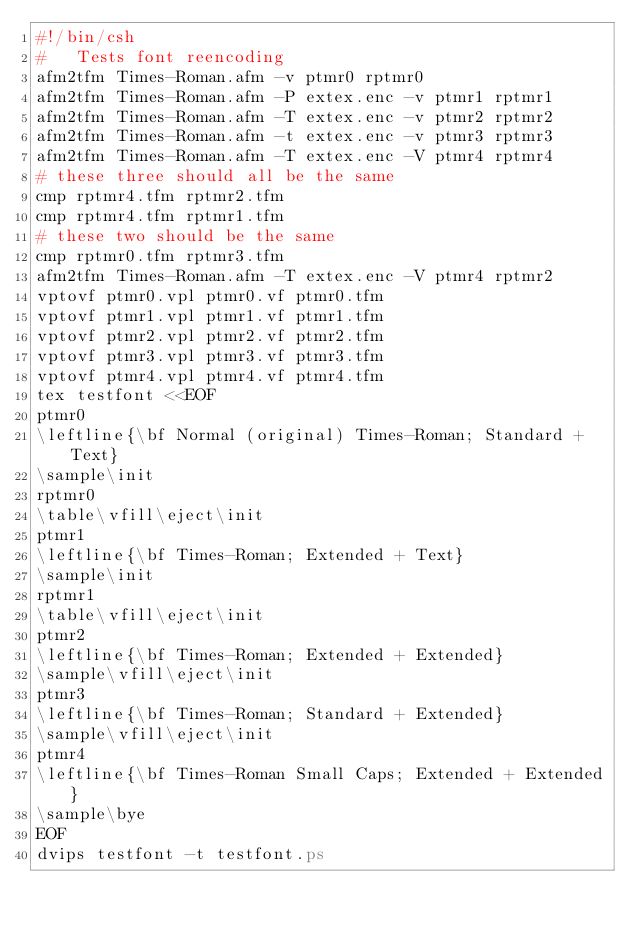Convert code to text. <code><loc_0><loc_0><loc_500><loc_500><_Bash_>#!/bin/csh
#   Tests font reencoding
afm2tfm Times-Roman.afm -v ptmr0 rptmr0
afm2tfm Times-Roman.afm -P extex.enc -v ptmr1 rptmr1
afm2tfm Times-Roman.afm -T extex.enc -v ptmr2 rptmr2
afm2tfm Times-Roman.afm -t extex.enc -v ptmr3 rptmr3
afm2tfm Times-Roman.afm -T extex.enc -V ptmr4 rptmr4
# these three should all be the same
cmp rptmr4.tfm rptmr2.tfm
cmp rptmr4.tfm rptmr1.tfm
# these two should be the same
cmp rptmr0.tfm rptmr3.tfm
afm2tfm Times-Roman.afm -T extex.enc -V ptmr4 rptmr2
vptovf ptmr0.vpl ptmr0.vf ptmr0.tfm
vptovf ptmr1.vpl ptmr1.vf ptmr1.tfm
vptovf ptmr2.vpl ptmr2.vf ptmr2.tfm
vptovf ptmr3.vpl ptmr3.vf ptmr3.tfm
vptovf ptmr4.vpl ptmr4.vf ptmr4.tfm
tex testfont <<EOF
ptmr0
\leftline{\bf Normal (original) Times-Roman; Standard + Text}
\sample\init
rptmr0
\table\vfill\eject\init
ptmr1
\leftline{\bf Times-Roman; Extended + Text}
\sample\init
rptmr1
\table\vfill\eject\init
ptmr2
\leftline{\bf Times-Roman; Extended + Extended}
\sample\vfill\eject\init
ptmr3
\leftline{\bf Times-Roman; Standard + Extended}
\sample\vfill\eject\init
ptmr4
\leftline{\bf Times-Roman Small Caps; Extended + Extended}
\sample\bye
EOF
dvips testfont -t testfont.ps
</code> 